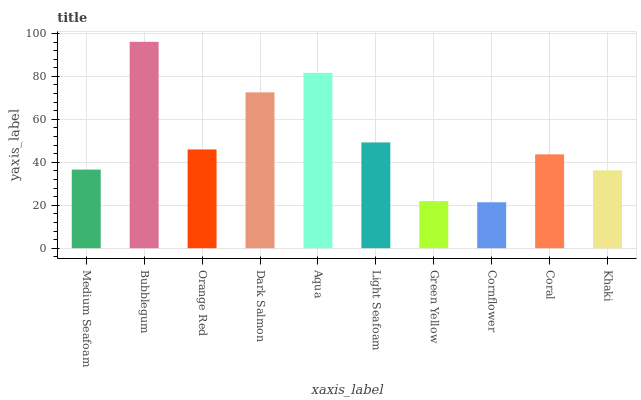Is Cornflower the minimum?
Answer yes or no. Yes. Is Bubblegum the maximum?
Answer yes or no. Yes. Is Orange Red the minimum?
Answer yes or no. No. Is Orange Red the maximum?
Answer yes or no. No. Is Bubblegum greater than Orange Red?
Answer yes or no. Yes. Is Orange Red less than Bubblegum?
Answer yes or no. Yes. Is Orange Red greater than Bubblegum?
Answer yes or no. No. Is Bubblegum less than Orange Red?
Answer yes or no. No. Is Orange Red the high median?
Answer yes or no. Yes. Is Coral the low median?
Answer yes or no. Yes. Is Khaki the high median?
Answer yes or no. No. Is Cornflower the low median?
Answer yes or no. No. 